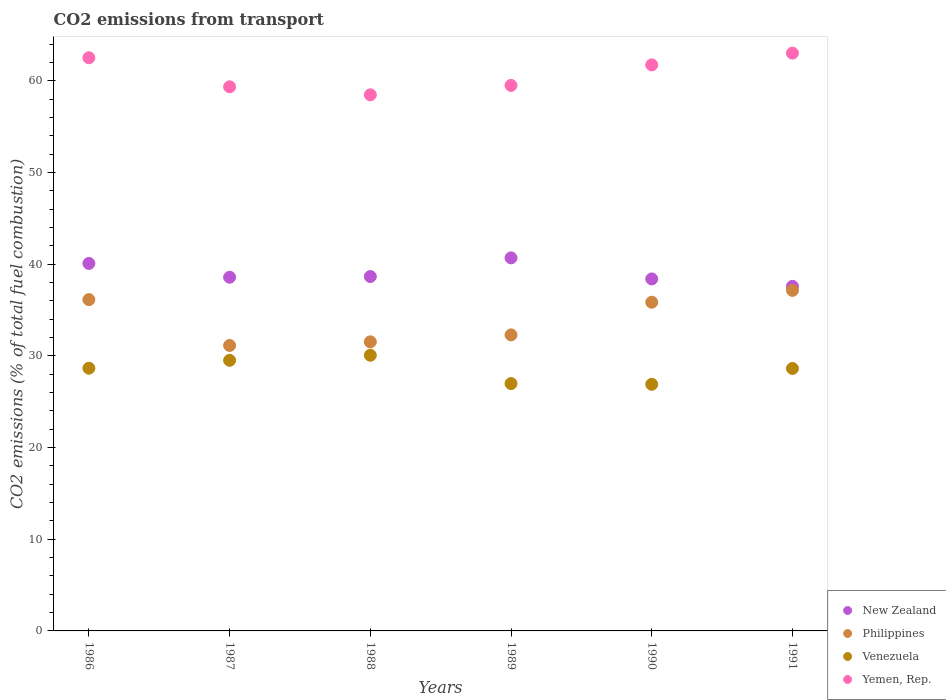Is the number of dotlines equal to the number of legend labels?
Make the answer very short. Yes. What is the total CO2 emitted in New Zealand in 1990?
Your answer should be very brief. 38.4. Across all years, what is the maximum total CO2 emitted in Venezuela?
Offer a very short reply. 30.07. Across all years, what is the minimum total CO2 emitted in New Zealand?
Your answer should be compact. 37.59. In which year was the total CO2 emitted in Venezuela minimum?
Ensure brevity in your answer.  1990. What is the total total CO2 emitted in Venezuela in the graph?
Provide a succinct answer. 170.76. What is the difference between the total CO2 emitted in New Zealand in 1987 and that in 1991?
Provide a succinct answer. 0.99. What is the difference between the total CO2 emitted in Venezuela in 1991 and the total CO2 emitted in Philippines in 1989?
Offer a very short reply. -3.66. What is the average total CO2 emitted in New Zealand per year?
Your response must be concise. 39. In the year 1988, what is the difference between the total CO2 emitted in New Zealand and total CO2 emitted in Philippines?
Offer a terse response. 7.12. In how many years, is the total CO2 emitted in Venezuela greater than 26?
Your answer should be very brief. 6. What is the ratio of the total CO2 emitted in Yemen, Rep. in 1988 to that in 1991?
Your answer should be compact. 0.93. Is the difference between the total CO2 emitted in New Zealand in 1986 and 1989 greater than the difference between the total CO2 emitted in Philippines in 1986 and 1989?
Your answer should be very brief. No. What is the difference between the highest and the second highest total CO2 emitted in Venezuela?
Provide a succinct answer. 0.55. What is the difference between the highest and the lowest total CO2 emitted in Venezuela?
Provide a succinct answer. 3.17. Does the total CO2 emitted in Philippines monotonically increase over the years?
Keep it short and to the point. No. Are the values on the major ticks of Y-axis written in scientific E-notation?
Keep it short and to the point. No. Does the graph contain any zero values?
Give a very brief answer. No. Does the graph contain grids?
Your answer should be compact. No. How many legend labels are there?
Your answer should be very brief. 4. How are the legend labels stacked?
Your answer should be very brief. Vertical. What is the title of the graph?
Your response must be concise. CO2 emissions from transport. What is the label or title of the X-axis?
Offer a terse response. Years. What is the label or title of the Y-axis?
Your answer should be very brief. CO2 emissions (% of total fuel combustion). What is the CO2 emissions (% of total fuel combustion) of New Zealand in 1986?
Keep it short and to the point. 40.09. What is the CO2 emissions (% of total fuel combustion) in Philippines in 1986?
Your response must be concise. 36.14. What is the CO2 emissions (% of total fuel combustion) in Venezuela in 1986?
Offer a very short reply. 28.66. What is the CO2 emissions (% of total fuel combustion) in Yemen, Rep. in 1986?
Keep it short and to the point. 62.52. What is the CO2 emissions (% of total fuel combustion) of New Zealand in 1987?
Offer a terse response. 38.58. What is the CO2 emissions (% of total fuel combustion) in Philippines in 1987?
Your response must be concise. 31.14. What is the CO2 emissions (% of total fuel combustion) of Venezuela in 1987?
Provide a short and direct response. 29.52. What is the CO2 emissions (% of total fuel combustion) in Yemen, Rep. in 1987?
Provide a succinct answer. 59.35. What is the CO2 emissions (% of total fuel combustion) in New Zealand in 1988?
Your answer should be very brief. 38.66. What is the CO2 emissions (% of total fuel combustion) in Philippines in 1988?
Keep it short and to the point. 31.53. What is the CO2 emissions (% of total fuel combustion) in Venezuela in 1988?
Keep it short and to the point. 30.07. What is the CO2 emissions (% of total fuel combustion) of Yemen, Rep. in 1988?
Provide a short and direct response. 58.48. What is the CO2 emissions (% of total fuel combustion) of New Zealand in 1989?
Your answer should be compact. 40.69. What is the CO2 emissions (% of total fuel combustion) of Philippines in 1989?
Give a very brief answer. 32.3. What is the CO2 emissions (% of total fuel combustion) in Venezuela in 1989?
Ensure brevity in your answer.  26.98. What is the CO2 emissions (% of total fuel combustion) of Yemen, Rep. in 1989?
Offer a terse response. 59.51. What is the CO2 emissions (% of total fuel combustion) of New Zealand in 1990?
Provide a short and direct response. 38.4. What is the CO2 emissions (% of total fuel combustion) in Philippines in 1990?
Your answer should be compact. 35.86. What is the CO2 emissions (% of total fuel combustion) of Venezuela in 1990?
Offer a terse response. 26.9. What is the CO2 emissions (% of total fuel combustion) of Yemen, Rep. in 1990?
Your answer should be compact. 61.74. What is the CO2 emissions (% of total fuel combustion) in New Zealand in 1991?
Your answer should be compact. 37.59. What is the CO2 emissions (% of total fuel combustion) of Philippines in 1991?
Ensure brevity in your answer.  37.15. What is the CO2 emissions (% of total fuel combustion) of Venezuela in 1991?
Ensure brevity in your answer.  28.63. What is the CO2 emissions (% of total fuel combustion) of Yemen, Rep. in 1991?
Give a very brief answer. 63.03. Across all years, what is the maximum CO2 emissions (% of total fuel combustion) of New Zealand?
Offer a terse response. 40.69. Across all years, what is the maximum CO2 emissions (% of total fuel combustion) of Philippines?
Keep it short and to the point. 37.15. Across all years, what is the maximum CO2 emissions (% of total fuel combustion) in Venezuela?
Your answer should be very brief. 30.07. Across all years, what is the maximum CO2 emissions (% of total fuel combustion) of Yemen, Rep.?
Make the answer very short. 63.03. Across all years, what is the minimum CO2 emissions (% of total fuel combustion) in New Zealand?
Provide a succinct answer. 37.59. Across all years, what is the minimum CO2 emissions (% of total fuel combustion) of Philippines?
Provide a short and direct response. 31.14. Across all years, what is the minimum CO2 emissions (% of total fuel combustion) in Venezuela?
Give a very brief answer. 26.9. Across all years, what is the minimum CO2 emissions (% of total fuel combustion) in Yemen, Rep.?
Your answer should be compact. 58.48. What is the total CO2 emissions (% of total fuel combustion) in New Zealand in the graph?
Your response must be concise. 234. What is the total CO2 emissions (% of total fuel combustion) of Philippines in the graph?
Your response must be concise. 204.11. What is the total CO2 emissions (% of total fuel combustion) in Venezuela in the graph?
Your response must be concise. 170.76. What is the total CO2 emissions (% of total fuel combustion) in Yemen, Rep. in the graph?
Give a very brief answer. 364.63. What is the difference between the CO2 emissions (% of total fuel combustion) of New Zealand in 1986 and that in 1987?
Make the answer very short. 1.5. What is the difference between the CO2 emissions (% of total fuel combustion) of Philippines in 1986 and that in 1987?
Make the answer very short. 5. What is the difference between the CO2 emissions (% of total fuel combustion) in Venezuela in 1986 and that in 1987?
Your answer should be very brief. -0.86. What is the difference between the CO2 emissions (% of total fuel combustion) in Yemen, Rep. in 1986 and that in 1987?
Make the answer very short. 3.17. What is the difference between the CO2 emissions (% of total fuel combustion) in New Zealand in 1986 and that in 1988?
Offer a terse response. 1.43. What is the difference between the CO2 emissions (% of total fuel combustion) of Philippines in 1986 and that in 1988?
Ensure brevity in your answer.  4.61. What is the difference between the CO2 emissions (% of total fuel combustion) of Venezuela in 1986 and that in 1988?
Give a very brief answer. -1.41. What is the difference between the CO2 emissions (% of total fuel combustion) of Yemen, Rep. in 1986 and that in 1988?
Make the answer very short. 4.05. What is the difference between the CO2 emissions (% of total fuel combustion) of New Zealand in 1986 and that in 1989?
Your response must be concise. -0.61. What is the difference between the CO2 emissions (% of total fuel combustion) of Philippines in 1986 and that in 1989?
Keep it short and to the point. 3.84. What is the difference between the CO2 emissions (% of total fuel combustion) of Venezuela in 1986 and that in 1989?
Offer a terse response. 1.67. What is the difference between the CO2 emissions (% of total fuel combustion) in Yemen, Rep. in 1986 and that in 1989?
Provide a succinct answer. 3.02. What is the difference between the CO2 emissions (% of total fuel combustion) of New Zealand in 1986 and that in 1990?
Provide a succinct answer. 1.69. What is the difference between the CO2 emissions (% of total fuel combustion) of Philippines in 1986 and that in 1990?
Your answer should be very brief. 0.28. What is the difference between the CO2 emissions (% of total fuel combustion) of Venezuela in 1986 and that in 1990?
Make the answer very short. 1.76. What is the difference between the CO2 emissions (% of total fuel combustion) in Yemen, Rep. in 1986 and that in 1990?
Your response must be concise. 0.78. What is the difference between the CO2 emissions (% of total fuel combustion) of New Zealand in 1986 and that in 1991?
Your answer should be very brief. 2.5. What is the difference between the CO2 emissions (% of total fuel combustion) in Philippines in 1986 and that in 1991?
Your response must be concise. -1.01. What is the difference between the CO2 emissions (% of total fuel combustion) of Venezuela in 1986 and that in 1991?
Provide a short and direct response. 0.03. What is the difference between the CO2 emissions (% of total fuel combustion) of Yemen, Rep. in 1986 and that in 1991?
Provide a succinct answer. -0.5. What is the difference between the CO2 emissions (% of total fuel combustion) of New Zealand in 1987 and that in 1988?
Your response must be concise. -0.08. What is the difference between the CO2 emissions (% of total fuel combustion) of Philippines in 1987 and that in 1988?
Give a very brief answer. -0.39. What is the difference between the CO2 emissions (% of total fuel combustion) in Venezuela in 1987 and that in 1988?
Offer a terse response. -0.55. What is the difference between the CO2 emissions (% of total fuel combustion) in Yemen, Rep. in 1987 and that in 1988?
Make the answer very short. 0.88. What is the difference between the CO2 emissions (% of total fuel combustion) in New Zealand in 1987 and that in 1989?
Provide a short and direct response. -2.11. What is the difference between the CO2 emissions (% of total fuel combustion) of Philippines in 1987 and that in 1989?
Make the answer very short. -1.16. What is the difference between the CO2 emissions (% of total fuel combustion) of Venezuela in 1987 and that in 1989?
Offer a terse response. 2.54. What is the difference between the CO2 emissions (% of total fuel combustion) in Yemen, Rep. in 1987 and that in 1989?
Make the answer very short. -0.15. What is the difference between the CO2 emissions (% of total fuel combustion) of New Zealand in 1987 and that in 1990?
Keep it short and to the point. 0.19. What is the difference between the CO2 emissions (% of total fuel combustion) in Philippines in 1987 and that in 1990?
Give a very brief answer. -4.72. What is the difference between the CO2 emissions (% of total fuel combustion) in Venezuela in 1987 and that in 1990?
Give a very brief answer. 2.62. What is the difference between the CO2 emissions (% of total fuel combustion) of Yemen, Rep. in 1987 and that in 1990?
Your response must be concise. -2.39. What is the difference between the CO2 emissions (% of total fuel combustion) of Philippines in 1987 and that in 1991?
Your answer should be compact. -6.01. What is the difference between the CO2 emissions (% of total fuel combustion) in Venezuela in 1987 and that in 1991?
Make the answer very short. 0.89. What is the difference between the CO2 emissions (% of total fuel combustion) of Yemen, Rep. in 1987 and that in 1991?
Your response must be concise. -3.67. What is the difference between the CO2 emissions (% of total fuel combustion) in New Zealand in 1988 and that in 1989?
Offer a terse response. -2.04. What is the difference between the CO2 emissions (% of total fuel combustion) in Philippines in 1988 and that in 1989?
Offer a terse response. -0.76. What is the difference between the CO2 emissions (% of total fuel combustion) of Venezuela in 1988 and that in 1989?
Offer a very short reply. 3.09. What is the difference between the CO2 emissions (% of total fuel combustion) in Yemen, Rep. in 1988 and that in 1989?
Your answer should be compact. -1.03. What is the difference between the CO2 emissions (% of total fuel combustion) in New Zealand in 1988 and that in 1990?
Your answer should be very brief. 0.26. What is the difference between the CO2 emissions (% of total fuel combustion) in Philippines in 1988 and that in 1990?
Give a very brief answer. -4.32. What is the difference between the CO2 emissions (% of total fuel combustion) in Venezuela in 1988 and that in 1990?
Provide a short and direct response. 3.17. What is the difference between the CO2 emissions (% of total fuel combustion) in Yemen, Rep. in 1988 and that in 1990?
Offer a very short reply. -3.26. What is the difference between the CO2 emissions (% of total fuel combustion) of New Zealand in 1988 and that in 1991?
Your response must be concise. 1.07. What is the difference between the CO2 emissions (% of total fuel combustion) of Philippines in 1988 and that in 1991?
Your answer should be very brief. -5.61. What is the difference between the CO2 emissions (% of total fuel combustion) in Venezuela in 1988 and that in 1991?
Give a very brief answer. 1.44. What is the difference between the CO2 emissions (% of total fuel combustion) in Yemen, Rep. in 1988 and that in 1991?
Make the answer very short. -4.55. What is the difference between the CO2 emissions (% of total fuel combustion) of New Zealand in 1989 and that in 1990?
Offer a very short reply. 2.3. What is the difference between the CO2 emissions (% of total fuel combustion) of Philippines in 1989 and that in 1990?
Offer a very short reply. -3.56. What is the difference between the CO2 emissions (% of total fuel combustion) in Venezuela in 1989 and that in 1990?
Your response must be concise. 0.08. What is the difference between the CO2 emissions (% of total fuel combustion) in Yemen, Rep. in 1989 and that in 1990?
Keep it short and to the point. -2.24. What is the difference between the CO2 emissions (% of total fuel combustion) in New Zealand in 1989 and that in 1991?
Provide a succinct answer. 3.11. What is the difference between the CO2 emissions (% of total fuel combustion) in Philippines in 1989 and that in 1991?
Offer a terse response. -4.85. What is the difference between the CO2 emissions (% of total fuel combustion) in Venezuela in 1989 and that in 1991?
Your response must be concise. -1.65. What is the difference between the CO2 emissions (% of total fuel combustion) in Yemen, Rep. in 1989 and that in 1991?
Make the answer very short. -3.52. What is the difference between the CO2 emissions (% of total fuel combustion) in New Zealand in 1990 and that in 1991?
Provide a succinct answer. 0.81. What is the difference between the CO2 emissions (% of total fuel combustion) of Philippines in 1990 and that in 1991?
Give a very brief answer. -1.29. What is the difference between the CO2 emissions (% of total fuel combustion) in Venezuela in 1990 and that in 1991?
Provide a succinct answer. -1.73. What is the difference between the CO2 emissions (% of total fuel combustion) of Yemen, Rep. in 1990 and that in 1991?
Provide a succinct answer. -1.29. What is the difference between the CO2 emissions (% of total fuel combustion) in New Zealand in 1986 and the CO2 emissions (% of total fuel combustion) in Philippines in 1987?
Make the answer very short. 8.95. What is the difference between the CO2 emissions (% of total fuel combustion) in New Zealand in 1986 and the CO2 emissions (% of total fuel combustion) in Venezuela in 1987?
Your response must be concise. 10.57. What is the difference between the CO2 emissions (% of total fuel combustion) in New Zealand in 1986 and the CO2 emissions (% of total fuel combustion) in Yemen, Rep. in 1987?
Offer a very short reply. -19.27. What is the difference between the CO2 emissions (% of total fuel combustion) in Philippines in 1986 and the CO2 emissions (% of total fuel combustion) in Venezuela in 1987?
Make the answer very short. 6.62. What is the difference between the CO2 emissions (% of total fuel combustion) of Philippines in 1986 and the CO2 emissions (% of total fuel combustion) of Yemen, Rep. in 1987?
Ensure brevity in your answer.  -23.21. What is the difference between the CO2 emissions (% of total fuel combustion) of Venezuela in 1986 and the CO2 emissions (% of total fuel combustion) of Yemen, Rep. in 1987?
Your response must be concise. -30.7. What is the difference between the CO2 emissions (% of total fuel combustion) in New Zealand in 1986 and the CO2 emissions (% of total fuel combustion) in Philippines in 1988?
Your response must be concise. 8.55. What is the difference between the CO2 emissions (% of total fuel combustion) of New Zealand in 1986 and the CO2 emissions (% of total fuel combustion) of Venezuela in 1988?
Give a very brief answer. 10.01. What is the difference between the CO2 emissions (% of total fuel combustion) in New Zealand in 1986 and the CO2 emissions (% of total fuel combustion) in Yemen, Rep. in 1988?
Ensure brevity in your answer.  -18.39. What is the difference between the CO2 emissions (% of total fuel combustion) in Philippines in 1986 and the CO2 emissions (% of total fuel combustion) in Venezuela in 1988?
Offer a terse response. 6.07. What is the difference between the CO2 emissions (% of total fuel combustion) in Philippines in 1986 and the CO2 emissions (% of total fuel combustion) in Yemen, Rep. in 1988?
Provide a succinct answer. -22.34. What is the difference between the CO2 emissions (% of total fuel combustion) in Venezuela in 1986 and the CO2 emissions (% of total fuel combustion) in Yemen, Rep. in 1988?
Keep it short and to the point. -29.82. What is the difference between the CO2 emissions (% of total fuel combustion) in New Zealand in 1986 and the CO2 emissions (% of total fuel combustion) in Philippines in 1989?
Your answer should be very brief. 7.79. What is the difference between the CO2 emissions (% of total fuel combustion) of New Zealand in 1986 and the CO2 emissions (% of total fuel combustion) of Venezuela in 1989?
Give a very brief answer. 13.1. What is the difference between the CO2 emissions (% of total fuel combustion) of New Zealand in 1986 and the CO2 emissions (% of total fuel combustion) of Yemen, Rep. in 1989?
Offer a terse response. -19.42. What is the difference between the CO2 emissions (% of total fuel combustion) in Philippines in 1986 and the CO2 emissions (% of total fuel combustion) in Venezuela in 1989?
Keep it short and to the point. 9.16. What is the difference between the CO2 emissions (% of total fuel combustion) in Philippines in 1986 and the CO2 emissions (% of total fuel combustion) in Yemen, Rep. in 1989?
Your answer should be very brief. -23.37. What is the difference between the CO2 emissions (% of total fuel combustion) of Venezuela in 1986 and the CO2 emissions (% of total fuel combustion) of Yemen, Rep. in 1989?
Your response must be concise. -30.85. What is the difference between the CO2 emissions (% of total fuel combustion) of New Zealand in 1986 and the CO2 emissions (% of total fuel combustion) of Philippines in 1990?
Offer a very short reply. 4.23. What is the difference between the CO2 emissions (% of total fuel combustion) in New Zealand in 1986 and the CO2 emissions (% of total fuel combustion) in Venezuela in 1990?
Your answer should be very brief. 13.19. What is the difference between the CO2 emissions (% of total fuel combustion) in New Zealand in 1986 and the CO2 emissions (% of total fuel combustion) in Yemen, Rep. in 1990?
Your answer should be very brief. -21.66. What is the difference between the CO2 emissions (% of total fuel combustion) of Philippines in 1986 and the CO2 emissions (% of total fuel combustion) of Venezuela in 1990?
Your answer should be compact. 9.24. What is the difference between the CO2 emissions (% of total fuel combustion) in Philippines in 1986 and the CO2 emissions (% of total fuel combustion) in Yemen, Rep. in 1990?
Ensure brevity in your answer.  -25.6. What is the difference between the CO2 emissions (% of total fuel combustion) in Venezuela in 1986 and the CO2 emissions (% of total fuel combustion) in Yemen, Rep. in 1990?
Your answer should be compact. -33.08. What is the difference between the CO2 emissions (% of total fuel combustion) of New Zealand in 1986 and the CO2 emissions (% of total fuel combustion) of Philippines in 1991?
Provide a succinct answer. 2.94. What is the difference between the CO2 emissions (% of total fuel combustion) of New Zealand in 1986 and the CO2 emissions (% of total fuel combustion) of Venezuela in 1991?
Your response must be concise. 11.46. What is the difference between the CO2 emissions (% of total fuel combustion) in New Zealand in 1986 and the CO2 emissions (% of total fuel combustion) in Yemen, Rep. in 1991?
Provide a short and direct response. -22.94. What is the difference between the CO2 emissions (% of total fuel combustion) in Philippines in 1986 and the CO2 emissions (% of total fuel combustion) in Venezuela in 1991?
Offer a very short reply. 7.51. What is the difference between the CO2 emissions (% of total fuel combustion) of Philippines in 1986 and the CO2 emissions (% of total fuel combustion) of Yemen, Rep. in 1991?
Your answer should be compact. -26.89. What is the difference between the CO2 emissions (% of total fuel combustion) of Venezuela in 1986 and the CO2 emissions (% of total fuel combustion) of Yemen, Rep. in 1991?
Your answer should be very brief. -34.37. What is the difference between the CO2 emissions (% of total fuel combustion) of New Zealand in 1987 and the CO2 emissions (% of total fuel combustion) of Philippines in 1988?
Your answer should be compact. 7.05. What is the difference between the CO2 emissions (% of total fuel combustion) of New Zealand in 1987 and the CO2 emissions (% of total fuel combustion) of Venezuela in 1988?
Your answer should be compact. 8.51. What is the difference between the CO2 emissions (% of total fuel combustion) in New Zealand in 1987 and the CO2 emissions (% of total fuel combustion) in Yemen, Rep. in 1988?
Ensure brevity in your answer.  -19.9. What is the difference between the CO2 emissions (% of total fuel combustion) in Philippines in 1987 and the CO2 emissions (% of total fuel combustion) in Venezuela in 1988?
Keep it short and to the point. 1.07. What is the difference between the CO2 emissions (% of total fuel combustion) of Philippines in 1987 and the CO2 emissions (% of total fuel combustion) of Yemen, Rep. in 1988?
Offer a terse response. -27.34. What is the difference between the CO2 emissions (% of total fuel combustion) in Venezuela in 1987 and the CO2 emissions (% of total fuel combustion) in Yemen, Rep. in 1988?
Ensure brevity in your answer.  -28.96. What is the difference between the CO2 emissions (% of total fuel combustion) of New Zealand in 1987 and the CO2 emissions (% of total fuel combustion) of Philippines in 1989?
Offer a very short reply. 6.29. What is the difference between the CO2 emissions (% of total fuel combustion) of New Zealand in 1987 and the CO2 emissions (% of total fuel combustion) of Venezuela in 1989?
Give a very brief answer. 11.6. What is the difference between the CO2 emissions (% of total fuel combustion) in New Zealand in 1987 and the CO2 emissions (% of total fuel combustion) in Yemen, Rep. in 1989?
Ensure brevity in your answer.  -20.92. What is the difference between the CO2 emissions (% of total fuel combustion) in Philippines in 1987 and the CO2 emissions (% of total fuel combustion) in Venezuela in 1989?
Give a very brief answer. 4.16. What is the difference between the CO2 emissions (% of total fuel combustion) in Philippines in 1987 and the CO2 emissions (% of total fuel combustion) in Yemen, Rep. in 1989?
Give a very brief answer. -28.37. What is the difference between the CO2 emissions (% of total fuel combustion) in Venezuela in 1987 and the CO2 emissions (% of total fuel combustion) in Yemen, Rep. in 1989?
Give a very brief answer. -29.99. What is the difference between the CO2 emissions (% of total fuel combustion) of New Zealand in 1987 and the CO2 emissions (% of total fuel combustion) of Philippines in 1990?
Offer a terse response. 2.73. What is the difference between the CO2 emissions (% of total fuel combustion) of New Zealand in 1987 and the CO2 emissions (% of total fuel combustion) of Venezuela in 1990?
Ensure brevity in your answer.  11.68. What is the difference between the CO2 emissions (% of total fuel combustion) of New Zealand in 1987 and the CO2 emissions (% of total fuel combustion) of Yemen, Rep. in 1990?
Offer a terse response. -23.16. What is the difference between the CO2 emissions (% of total fuel combustion) of Philippines in 1987 and the CO2 emissions (% of total fuel combustion) of Venezuela in 1990?
Your response must be concise. 4.24. What is the difference between the CO2 emissions (% of total fuel combustion) in Philippines in 1987 and the CO2 emissions (% of total fuel combustion) in Yemen, Rep. in 1990?
Give a very brief answer. -30.6. What is the difference between the CO2 emissions (% of total fuel combustion) in Venezuela in 1987 and the CO2 emissions (% of total fuel combustion) in Yemen, Rep. in 1990?
Keep it short and to the point. -32.22. What is the difference between the CO2 emissions (% of total fuel combustion) of New Zealand in 1987 and the CO2 emissions (% of total fuel combustion) of Philippines in 1991?
Offer a terse response. 1.43. What is the difference between the CO2 emissions (% of total fuel combustion) of New Zealand in 1987 and the CO2 emissions (% of total fuel combustion) of Venezuela in 1991?
Provide a short and direct response. 9.95. What is the difference between the CO2 emissions (% of total fuel combustion) in New Zealand in 1987 and the CO2 emissions (% of total fuel combustion) in Yemen, Rep. in 1991?
Offer a terse response. -24.45. What is the difference between the CO2 emissions (% of total fuel combustion) of Philippines in 1987 and the CO2 emissions (% of total fuel combustion) of Venezuela in 1991?
Offer a terse response. 2.51. What is the difference between the CO2 emissions (% of total fuel combustion) in Philippines in 1987 and the CO2 emissions (% of total fuel combustion) in Yemen, Rep. in 1991?
Offer a terse response. -31.89. What is the difference between the CO2 emissions (% of total fuel combustion) in Venezuela in 1987 and the CO2 emissions (% of total fuel combustion) in Yemen, Rep. in 1991?
Your response must be concise. -33.51. What is the difference between the CO2 emissions (% of total fuel combustion) in New Zealand in 1988 and the CO2 emissions (% of total fuel combustion) in Philippines in 1989?
Offer a very short reply. 6.36. What is the difference between the CO2 emissions (% of total fuel combustion) in New Zealand in 1988 and the CO2 emissions (% of total fuel combustion) in Venezuela in 1989?
Provide a succinct answer. 11.67. What is the difference between the CO2 emissions (% of total fuel combustion) of New Zealand in 1988 and the CO2 emissions (% of total fuel combustion) of Yemen, Rep. in 1989?
Keep it short and to the point. -20.85. What is the difference between the CO2 emissions (% of total fuel combustion) in Philippines in 1988 and the CO2 emissions (% of total fuel combustion) in Venezuela in 1989?
Keep it short and to the point. 4.55. What is the difference between the CO2 emissions (% of total fuel combustion) of Philippines in 1988 and the CO2 emissions (% of total fuel combustion) of Yemen, Rep. in 1989?
Offer a very short reply. -27.97. What is the difference between the CO2 emissions (% of total fuel combustion) of Venezuela in 1988 and the CO2 emissions (% of total fuel combustion) of Yemen, Rep. in 1989?
Make the answer very short. -29.43. What is the difference between the CO2 emissions (% of total fuel combustion) in New Zealand in 1988 and the CO2 emissions (% of total fuel combustion) in Philippines in 1990?
Your answer should be very brief. 2.8. What is the difference between the CO2 emissions (% of total fuel combustion) in New Zealand in 1988 and the CO2 emissions (% of total fuel combustion) in Venezuela in 1990?
Ensure brevity in your answer.  11.76. What is the difference between the CO2 emissions (% of total fuel combustion) of New Zealand in 1988 and the CO2 emissions (% of total fuel combustion) of Yemen, Rep. in 1990?
Your answer should be compact. -23.08. What is the difference between the CO2 emissions (% of total fuel combustion) in Philippines in 1988 and the CO2 emissions (% of total fuel combustion) in Venezuela in 1990?
Give a very brief answer. 4.63. What is the difference between the CO2 emissions (% of total fuel combustion) of Philippines in 1988 and the CO2 emissions (% of total fuel combustion) of Yemen, Rep. in 1990?
Keep it short and to the point. -30.21. What is the difference between the CO2 emissions (% of total fuel combustion) of Venezuela in 1988 and the CO2 emissions (% of total fuel combustion) of Yemen, Rep. in 1990?
Your response must be concise. -31.67. What is the difference between the CO2 emissions (% of total fuel combustion) in New Zealand in 1988 and the CO2 emissions (% of total fuel combustion) in Philippines in 1991?
Your answer should be compact. 1.51. What is the difference between the CO2 emissions (% of total fuel combustion) in New Zealand in 1988 and the CO2 emissions (% of total fuel combustion) in Venezuela in 1991?
Offer a very short reply. 10.03. What is the difference between the CO2 emissions (% of total fuel combustion) in New Zealand in 1988 and the CO2 emissions (% of total fuel combustion) in Yemen, Rep. in 1991?
Offer a very short reply. -24.37. What is the difference between the CO2 emissions (% of total fuel combustion) in Philippines in 1988 and the CO2 emissions (% of total fuel combustion) in Venezuela in 1991?
Provide a succinct answer. 2.9. What is the difference between the CO2 emissions (% of total fuel combustion) in Philippines in 1988 and the CO2 emissions (% of total fuel combustion) in Yemen, Rep. in 1991?
Your answer should be very brief. -31.49. What is the difference between the CO2 emissions (% of total fuel combustion) in Venezuela in 1988 and the CO2 emissions (% of total fuel combustion) in Yemen, Rep. in 1991?
Ensure brevity in your answer.  -32.96. What is the difference between the CO2 emissions (% of total fuel combustion) in New Zealand in 1989 and the CO2 emissions (% of total fuel combustion) in Philippines in 1990?
Your answer should be compact. 4.84. What is the difference between the CO2 emissions (% of total fuel combustion) of New Zealand in 1989 and the CO2 emissions (% of total fuel combustion) of Venezuela in 1990?
Your answer should be compact. 13.79. What is the difference between the CO2 emissions (% of total fuel combustion) of New Zealand in 1989 and the CO2 emissions (% of total fuel combustion) of Yemen, Rep. in 1990?
Make the answer very short. -21.05. What is the difference between the CO2 emissions (% of total fuel combustion) of Philippines in 1989 and the CO2 emissions (% of total fuel combustion) of Venezuela in 1990?
Ensure brevity in your answer.  5.39. What is the difference between the CO2 emissions (% of total fuel combustion) in Philippines in 1989 and the CO2 emissions (% of total fuel combustion) in Yemen, Rep. in 1990?
Ensure brevity in your answer.  -29.45. What is the difference between the CO2 emissions (% of total fuel combustion) of Venezuela in 1989 and the CO2 emissions (% of total fuel combustion) of Yemen, Rep. in 1990?
Offer a terse response. -34.76. What is the difference between the CO2 emissions (% of total fuel combustion) of New Zealand in 1989 and the CO2 emissions (% of total fuel combustion) of Philippines in 1991?
Your answer should be very brief. 3.55. What is the difference between the CO2 emissions (% of total fuel combustion) of New Zealand in 1989 and the CO2 emissions (% of total fuel combustion) of Venezuela in 1991?
Your answer should be compact. 12.06. What is the difference between the CO2 emissions (% of total fuel combustion) in New Zealand in 1989 and the CO2 emissions (% of total fuel combustion) in Yemen, Rep. in 1991?
Ensure brevity in your answer.  -22.33. What is the difference between the CO2 emissions (% of total fuel combustion) of Philippines in 1989 and the CO2 emissions (% of total fuel combustion) of Venezuela in 1991?
Give a very brief answer. 3.66. What is the difference between the CO2 emissions (% of total fuel combustion) of Philippines in 1989 and the CO2 emissions (% of total fuel combustion) of Yemen, Rep. in 1991?
Make the answer very short. -30.73. What is the difference between the CO2 emissions (% of total fuel combustion) of Venezuela in 1989 and the CO2 emissions (% of total fuel combustion) of Yemen, Rep. in 1991?
Keep it short and to the point. -36.04. What is the difference between the CO2 emissions (% of total fuel combustion) in New Zealand in 1990 and the CO2 emissions (% of total fuel combustion) in Philippines in 1991?
Make the answer very short. 1.25. What is the difference between the CO2 emissions (% of total fuel combustion) in New Zealand in 1990 and the CO2 emissions (% of total fuel combustion) in Venezuela in 1991?
Keep it short and to the point. 9.77. What is the difference between the CO2 emissions (% of total fuel combustion) of New Zealand in 1990 and the CO2 emissions (% of total fuel combustion) of Yemen, Rep. in 1991?
Offer a very short reply. -24.63. What is the difference between the CO2 emissions (% of total fuel combustion) of Philippines in 1990 and the CO2 emissions (% of total fuel combustion) of Venezuela in 1991?
Your answer should be very brief. 7.23. What is the difference between the CO2 emissions (% of total fuel combustion) in Philippines in 1990 and the CO2 emissions (% of total fuel combustion) in Yemen, Rep. in 1991?
Your answer should be very brief. -27.17. What is the difference between the CO2 emissions (% of total fuel combustion) in Venezuela in 1990 and the CO2 emissions (% of total fuel combustion) in Yemen, Rep. in 1991?
Make the answer very short. -36.13. What is the average CO2 emissions (% of total fuel combustion) in New Zealand per year?
Your answer should be compact. 39. What is the average CO2 emissions (% of total fuel combustion) of Philippines per year?
Give a very brief answer. 34.02. What is the average CO2 emissions (% of total fuel combustion) of Venezuela per year?
Your response must be concise. 28.46. What is the average CO2 emissions (% of total fuel combustion) of Yemen, Rep. per year?
Give a very brief answer. 60.77. In the year 1986, what is the difference between the CO2 emissions (% of total fuel combustion) in New Zealand and CO2 emissions (% of total fuel combustion) in Philippines?
Ensure brevity in your answer.  3.95. In the year 1986, what is the difference between the CO2 emissions (% of total fuel combustion) in New Zealand and CO2 emissions (% of total fuel combustion) in Venezuela?
Offer a very short reply. 11.43. In the year 1986, what is the difference between the CO2 emissions (% of total fuel combustion) of New Zealand and CO2 emissions (% of total fuel combustion) of Yemen, Rep.?
Make the answer very short. -22.44. In the year 1986, what is the difference between the CO2 emissions (% of total fuel combustion) in Philippines and CO2 emissions (% of total fuel combustion) in Venezuela?
Ensure brevity in your answer.  7.48. In the year 1986, what is the difference between the CO2 emissions (% of total fuel combustion) of Philippines and CO2 emissions (% of total fuel combustion) of Yemen, Rep.?
Offer a very short reply. -26.38. In the year 1986, what is the difference between the CO2 emissions (% of total fuel combustion) of Venezuela and CO2 emissions (% of total fuel combustion) of Yemen, Rep.?
Ensure brevity in your answer.  -33.87. In the year 1987, what is the difference between the CO2 emissions (% of total fuel combustion) in New Zealand and CO2 emissions (% of total fuel combustion) in Philippines?
Your answer should be very brief. 7.44. In the year 1987, what is the difference between the CO2 emissions (% of total fuel combustion) of New Zealand and CO2 emissions (% of total fuel combustion) of Venezuela?
Provide a short and direct response. 9.06. In the year 1987, what is the difference between the CO2 emissions (% of total fuel combustion) of New Zealand and CO2 emissions (% of total fuel combustion) of Yemen, Rep.?
Your answer should be very brief. -20.77. In the year 1987, what is the difference between the CO2 emissions (% of total fuel combustion) in Philippines and CO2 emissions (% of total fuel combustion) in Venezuela?
Ensure brevity in your answer.  1.62. In the year 1987, what is the difference between the CO2 emissions (% of total fuel combustion) in Philippines and CO2 emissions (% of total fuel combustion) in Yemen, Rep.?
Make the answer very short. -28.21. In the year 1987, what is the difference between the CO2 emissions (% of total fuel combustion) of Venezuela and CO2 emissions (% of total fuel combustion) of Yemen, Rep.?
Ensure brevity in your answer.  -29.83. In the year 1988, what is the difference between the CO2 emissions (% of total fuel combustion) of New Zealand and CO2 emissions (% of total fuel combustion) of Philippines?
Offer a very short reply. 7.12. In the year 1988, what is the difference between the CO2 emissions (% of total fuel combustion) of New Zealand and CO2 emissions (% of total fuel combustion) of Venezuela?
Provide a succinct answer. 8.59. In the year 1988, what is the difference between the CO2 emissions (% of total fuel combustion) of New Zealand and CO2 emissions (% of total fuel combustion) of Yemen, Rep.?
Offer a very short reply. -19.82. In the year 1988, what is the difference between the CO2 emissions (% of total fuel combustion) of Philippines and CO2 emissions (% of total fuel combustion) of Venezuela?
Give a very brief answer. 1.46. In the year 1988, what is the difference between the CO2 emissions (% of total fuel combustion) in Philippines and CO2 emissions (% of total fuel combustion) in Yemen, Rep.?
Provide a succinct answer. -26.95. In the year 1988, what is the difference between the CO2 emissions (% of total fuel combustion) of Venezuela and CO2 emissions (% of total fuel combustion) of Yemen, Rep.?
Make the answer very short. -28.41. In the year 1989, what is the difference between the CO2 emissions (% of total fuel combustion) of New Zealand and CO2 emissions (% of total fuel combustion) of Philippines?
Make the answer very short. 8.4. In the year 1989, what is the difference between the CO2 emissions (% of total fuel combustion) in New Zealand and CO2 emissions (% of total fuel combustion) in Venezuela?
Provide a succinct answer. 13.71. In the year 1989, what is the difference between the CO2 emissions (% of total fuel combustion) of New Zealand and CO2 emissions (% of total fuel combustion) of Yemen, Rep.?
Your response must be concise. -18.81. In the year 1989, what is the difference between the CO2 emissions (% of total fuel combustion) in Philippines and CO2 emissions (% of total fuel combustion) in Venezuela?
Provide a succinct answer. 5.31. In the year 1989, what is the difference between the CO2 emissions (% of total fuel combustion) in Philippines and CO2 emissions (% of total fuel combustion) in Yemen, Rep.?
Keep it short and to the point. -27.21. In the year 1989, what is the difference between the CO2 emissions (% of total fuel combustion) in Venezuela and CO2 emissions (% of total fuel combustion) in Yemen, Rep.?
Provide a short and direct response. -32.52. In the year 1990, what is the difference between the CO2 emissions (% of total fuel combustion) of New Zealand and CO2 emissions (% of total fuel combustion) of Philippines?
Your response must be concise. 2.54. In the year 1990, what is the difference between the CO2 emissions (% of total fuel combustion) of New Zealand and CO2 emissions (% of total fuel combustion) of Venezuela?
Offer a very short reply. 11.5. In the year 1990, what is the difference between the CO2 emissions (% of total fuel combustion) of New Zealand and CO2 emissions (% of total fuel combustion) of Yemen, Rep.?
Offer a very short reply. -23.35. In the year 1990, what is the difference between the CO2 emissions (% of total fuel combustion) in Philippines and CO2 emissions (% of total fuel combustion) in Venezuela?
Your response must be concise. 8.95. In the year 1990, what is the difference between the CO2 emissions (% of total fuel combustion) in Philippines and CO2 emissions (% of total fuel combustion) in Yemen, Rep.?
Your response must be concise. -25.89. In the year 1990, what is the difference between the CO2 emissions (% of total fuel combustion) of Venezuela and CO2 emissions (% of total fuel combustion) of Yemen, Rep.?
Provide a short and direct response. -34.84. In the year 1991, what is the difference between the CO2 emissions (% of total fuel combustion) in New Zealand and CO2 emissions (% of total fuel combustion) in Philippines?
Make the answer very short. 0.44. In the year 1991, what is the difference between the CO2 emissions (% of total fuel combustion) of New Zealand and CO2 emissions (% of total fuel combustion) of Venezuela?
Make the answer very short. 8.96. In the year 1991, what is the difference between the CO2 emissions (% of total fuel combustion) in New Zealand and CO2 emissions (% of total fuel combustion) in Yemen, Rep.?
Offer a very short reply. -25.44. In the year 1991, what is the difference between the CO2 emissions (% of total fuel combustion) of Philippines and CO2 emissions (% of total fuel combustion) of Venezuela?
Ensure brevity in your answer.  8.52. In the year 1991, what is the difference between the CO2 emissions (% of total fuel combustion) of Philippines and CO2 emissions (% of total fuel combustion) of Yemen, Rep.?
Your answer should be very brief. -25.88. In the year 1991, what is the difference between the CO2 emissions (% of total fuel combustion) in Venezuela and CO2 emissions (% of total fuel combustion) in Yemen, Rep.?
Give a very brief answer. -34.4. What is the ratio of the CO2 emissions (% of total fuel combustion) in New Zealand in 1986 to that in 1987?
Offer a very short reply. 1.04. What is the ratio of the CO2 emissions (% of total fuel combustion) in Philippines in 1986 to that in 1987?
Ensure brevity in your answer.  1.16. What is the ratio of the CO2 emissions (% of total fuel combustion) in Venezuela in 1986 to that in 1987?
Ensure brevity in your answer.  0.97. What is the ratio of the CO2 emissions (% of total fuel combustion) of Yemen, Rep. in 1986 to that in 1987?
Your answer should be very brief. 1.05. What is the ratio of the CO2 emissions (% of total fuel combustion) in New Zealand in 1986 to that in 1988?
Your response must be concise. 1.04. What is the ratio of the CO2 emissions (% of total fuel combustion) of Philippines in 1986 to that in 1988?
Provide a succinct answer. 1.15. What is the ratio of the CO2 emissions (% of total fuel combustion) in Venezuela in 1986 to that in 1988?
Your answer should be very brief. 0.95. What is the ratio of the CO2 emissions (% of total fuel combustion) in Yemen, Rep. in 1986 to that in 1988?
Offer a very short reply. 1.07. What is the ratio of the CO2 emissions (% of total fuel combustion) in New Zealand in 1986 to that in 1989?
Your response must be concise. 0.99. What is the ratio of the CO2 emissions (% of total fuel combustion) in Philippines in 1986 to that in 1989?
Keep it short and to the point. 1.12. What is the ratio of the CO2 emissions (% of total fuel combustion) of Venezuela in 1986 to that in 1989?
Offer a terse response. 1.06. What is the ratio of the CO2 emissions (% of total fuel combustion) of Yemen, Rep. in 1986 to that in 1989?
Provide a short and direct response. 1.05. What is the ratio of the CO2 emissions (% of total fuel combustion) in New Zealand in 1986 to that in 1990?
Provide a succinct answer. 1.04. What is the ratio of the CO2 emissions (% of total fuel combustion) of Philippines in 1986 to that in 1990?
Ensure brevity in your answer.  1.01. What is the ratio of the CO2 emissions (% of total fuel combustion) in Venezuela in 1986 to that in 1990?
Offer a terse response. 1.07. What is the ratio of the CO2 emissions (% of total fuel combustion) of Yemen, Rep. in 1986 to that in 1990?
Make the answer very short. 1.01. What is the ratio of the CO2 emissions (% of total fuel combustion) of New Zealand in 1986 to that in 1991?
Ensure brevity in your answer.  1.07. What is the ratio of the CO2 emissions (% of total fuel combustion) in Philippines in 1986 to that in 1991?
Make the answer very short. 0.97. What is the ratio of the CO2 emissions (% of total fuel combustion) in Yemen, Rep. in 1986 to that in 1991?
Provide a short and direct response. 0.99. What is the ratio of the CO2 emissions (% of total fuel combustion) in New Zealand in 1987 to that in 1988?
Offer a very short reply. 1. What is the ratio of the CO2 emissions (% of total fuel combustion) in Philippines in 1987 to that in 1988?
Keep it short and to the point. 0.99. What is the ratio of the CO2 emissions (% of total fuel combustion) in Venezuela in 1987 to that in 1988?
Your answer should be very brief. 0.98. What is the ratio of the CO2 emissions (% of total fuel combustion) of Yemen, Rep. in 1987 to that in 1988?
Provide a succinct answer. 1.01. What is the ratio of the CO2 emissions (% of total fuel combustion) of New Zealand in 1987 to that in 1989?
Keep it short and to the point. 0.95. What is the ratio of the CO2 emissions (% of total fuel combustion) of Philippines in 1987 to that in 1989?
Offer a very short reply. 0.96. What is the ratio of the CO2 emissions (% of total fuel combustion) of Venezuela in 1987 to that in 1989?
Your answer should be compact. 1.09. What is the ratio of the CO2 emissions (% of total fuel combustion) of Philippines in 1987 to that in 1990?
Keep it short and to the point. 0.87. What is the ratio of the CO2 emissions (% of total fuel combustion) in Venezuela in 1987 to that in 1990?
Ensure brevity in your answer.  1.1. What is the ratio of the CO2 emissions (% of total fuel combustion) of Yemen, Rep. in 1987 to that in 1990?
Make the answer very short. 0.96. What is the ratio of the CO2 emissions (% of total fuel combustion) of New Zealand in 1987 to that in 1991?
Your response must be concise. 1.03. What is the ratio of the CO2 emissions (% of total fuel combustion) of Philippines in 1987 to that in 1991?
Offer a terse response. 0.84. What is the ratio of the CO2 emissions (% of total fuel combustion) in Venezuela in 1987 to that in 1991?
Your answer should be compact. 1.03. What is the ratio of the CO2 emissions (% of total fuel combustion) of Yemen, Rep. in 1987 to that in 1991?
Offer a very short reply. 0.94. What is the ratio of the CO2 emissions (% of total fuel combustion) of New Zealand in 1988 to that in 1989?
Keep it short and to the point. 0.95. What is the ratio of the CO2 emissions (% of total fuel combustion) of Philippines in 1988 to that in 1989?
Offer a very short reply. 0.98. What is the ratio of the CO2 emissions (% of total fuel combustion) of Venezuela in 1988 to that in 1989?
Your answer should be very brief. 1.11. What is the ratio of the CO2 emissions (% of total fuel combustion) of Yemen, Rep. in 1988 to that in 1989?
Offer a terse response. 0.98. What is the ratio of the CO2 emissions (% of total fuel combustion) of New Zealand in 1988 to that in 1990?
Give a very brief answer. 1.01. What is the ratio of the CO2 emissions (% of total fuel combustion) of Philippines in 1988 to that in 1990?
Offer a very short reply. 0.88. What is the ratio of the CO2 emissions (% of total fuel combustion) in Venezuela in 1988 to that in 1990?
Your answer should be very brief. 1.12. What is the ratio of the CO2 emissions (% of total fuel combustion) of Yemen, Rep. in 1988 to that in 1990?
Offer a terse response. 0.95. What is the ratio of the CO2 emissions (% of total fuel combustion) in New Zealand in 1988 to that in 1991?
Give a very brief answer. 1.03. What is the ratio of the CO2 emissions (% of total fuel combustion) in Philippines in 1988 to that in 1991?
Your answer should be very brief. 0.85. What is the ratio of the CO2 emissions (% of total fuel combustion) of Venezuela in 1988 to that in 1991?
Keep it short and to the point. 1.05. What is the ratio of the CO2 emissions (% of total fuel combustion) in Yemen, Rep. in 1988 to that in 1991?
Provide a short and direct response. 0.93. What is the ratio of the CO2 emissions (% of total fuel combustion) of New Zealand in 1989 to that in 1990?
Offer a very short reply. 1.06. What is the ratio of the CO2 emissions (% of total fuel combustion) in Philippines in 1989 to that in 1990?
Offer a terse response. 0.9. What is the ratio of the CO2 emissions (% of total fuel combustion) in Yemen, Rep. in 1989 to that in 1990?
Offer a terse response. 0.96. What is the ratio of the CO2 emissions (% of total fuel combustion) in New Zealand in 1989 to that in 1991?
Ensure brevity in your answer.  1.08. What is the ratio of the CO2 emissions (% of total fuel combustion) in Philippines in 1989 to that in 1991?
Your answer should be compact. 0.87. What is the ratio of the CO2 emissions (% of total fuel combustion) of Venezuela in 1989 to that in 1991?
Your answer should be compact. 0.94. What is the ratio of the CO2 emissions (% of total fuel combustion) in Yemen, Rep. in 1989 to that in 1991?
Ensure brevity in your answer.  0.94. What is the ratio of the CO2 emissions (% of total fuel combustion) of New Zealand in 1990 to that in 1991?
Provide a succinct answer. 1.02. What is the ratio of the CO2 emissions (% of total fuel combustion) in Philippines in 1990 to that in 1991?
Make the answer very short. 0.97. What is the ratio of the CO2 emissions (% of total fuel combustion) of Venezuela in 1990 to that in 1991?
Your answer should be compact. 0.94. What is the ratio of the CO2 emissions (% of total fuel combustion) in Yemen, Rep. in 1990 to that in 1991?
Keep it short and to the point. 0.98. What is the difference between the highest and the second highest CO2 emissions (% of total fuel combustion) of New Zealand?
Your answer should be compact. 0.61. What is the difference between the highest and the second highest CO2 emissions (% of total fuel combustion) in Venezuela?
Give a very brief answer. 0.55. What is the difference between the highest and the second highest CO2 emissions (% of total fuel combustion) in Yemen, Rep.?
Keep it short and to the point. 0.5. What is the difference between the highest and the lowest CO2 emissions (% of total fuel combustion) in New Zealand?
Provide a succinct answer. 3.11. What is the difference between the highest and the lowest CO2 emissions (% of total fuel combustion) of Philippines?
Your answer should be very brief. 6.01. What is the difference between the highest and the lowest CO2 emissions (% of total fuel combustion) in Venezuela?
Your answer should be very brief. 3.17. What is the difference between the highest and the lowest CO2 emissions (% of total fuel combustion) of Yemen, Rep.?
Your answer should be compact. 4.55. 